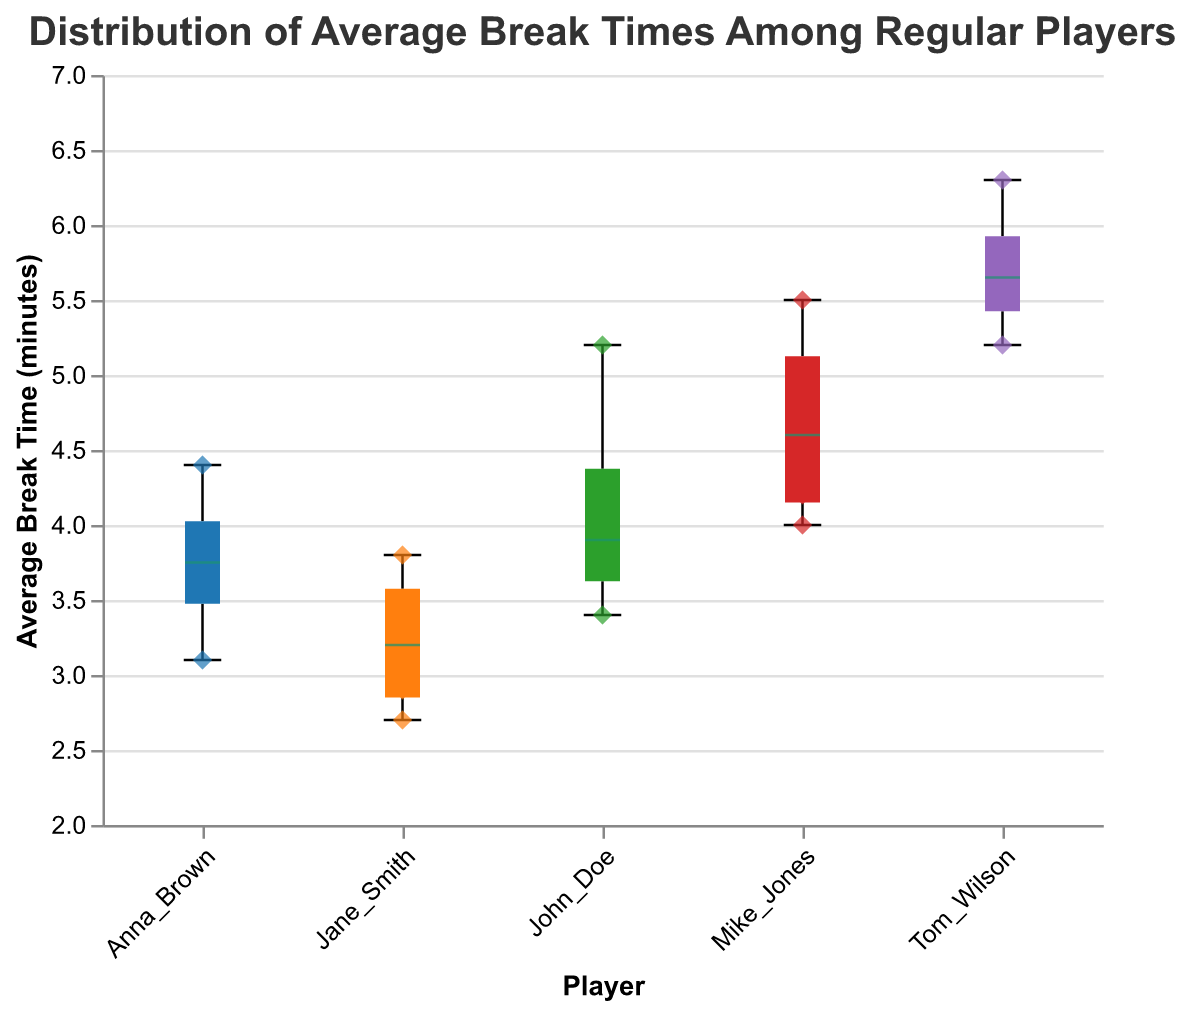What is the title of the figure? The title is written at the top of the figure in a larger font that stands out from the rest of the text.
Answer: Distribution of Average Break Times Among Regular Players What is the median average break time for John Doe? The median is marked with a distinct color line (green) in the box plot for each player. For John Doe, you can see this within the bounds of his box plot.
Answer: 4.1 minutes Which player has the highest maximum average break time? This can be determined by looking at the topmost point of the whisker for each player's box plot. Tom Wilson's whisker extends the highest on the y-axis.
Answer: Tom Wilson How many data points are there in total? You can count the number of scatter points for all players combined, each representing an average break time for one game. Given that there are 5 players and each has 4 data points (one per game), the total is 5 * 4.
Answer: 20 points What is the average of the median break times across all players? Find the medians marked in each box plot for all players (John Doe: 4.1, Jane Smith: 3.2, Mike Jones: 4.6, Anna Brown: 3.75, Tom Wilson: 5.55), then calculate the average of these values. (4.1 + 3.2 + 4.6 + 3.75 + 5.55) / 5 = 4.24 minutes.
Answer: 4.24 minutes Compare the interquartile ranges (IQR) of Jane Smith and Tom Wilson. Which is wider? IQR is the range from the first quartile (Q1) to the third quartile (Q3). From the box plots, the span of Jane Smith's box (Q3 - Q1) is smaller than that of Tom Wilson's box.
Answer: Tom Wilson's Which player has the lowest minimum average break time? This is determined by looking at the bottommost whisker of each player's box plot. Jane Smith's whisker reaches the lowest point.
Answer: Jane Smith Between which two players is the difference in their median break times the largest? Calculate the absolute difference between the median values of each pair of players and choose the pair with the largest difference:
Answer: The largest difference is between Jane Smith (3.2) and Tom Wilson (5.55). Difference: 5.55 - 3.2 = 2.35 minutes Which player has the most consistent break times, indicated by the smallest range of break times? The smallest range can be observed by looking at the shortest whisker span from the minimum to the maximum in the box plot.
Answer: Anna Brown What shape are the scatter points in the plot? The scatter points are consistently diamond-shaped, as indicated by their geometric form in the figure.
Answer: Diamond 